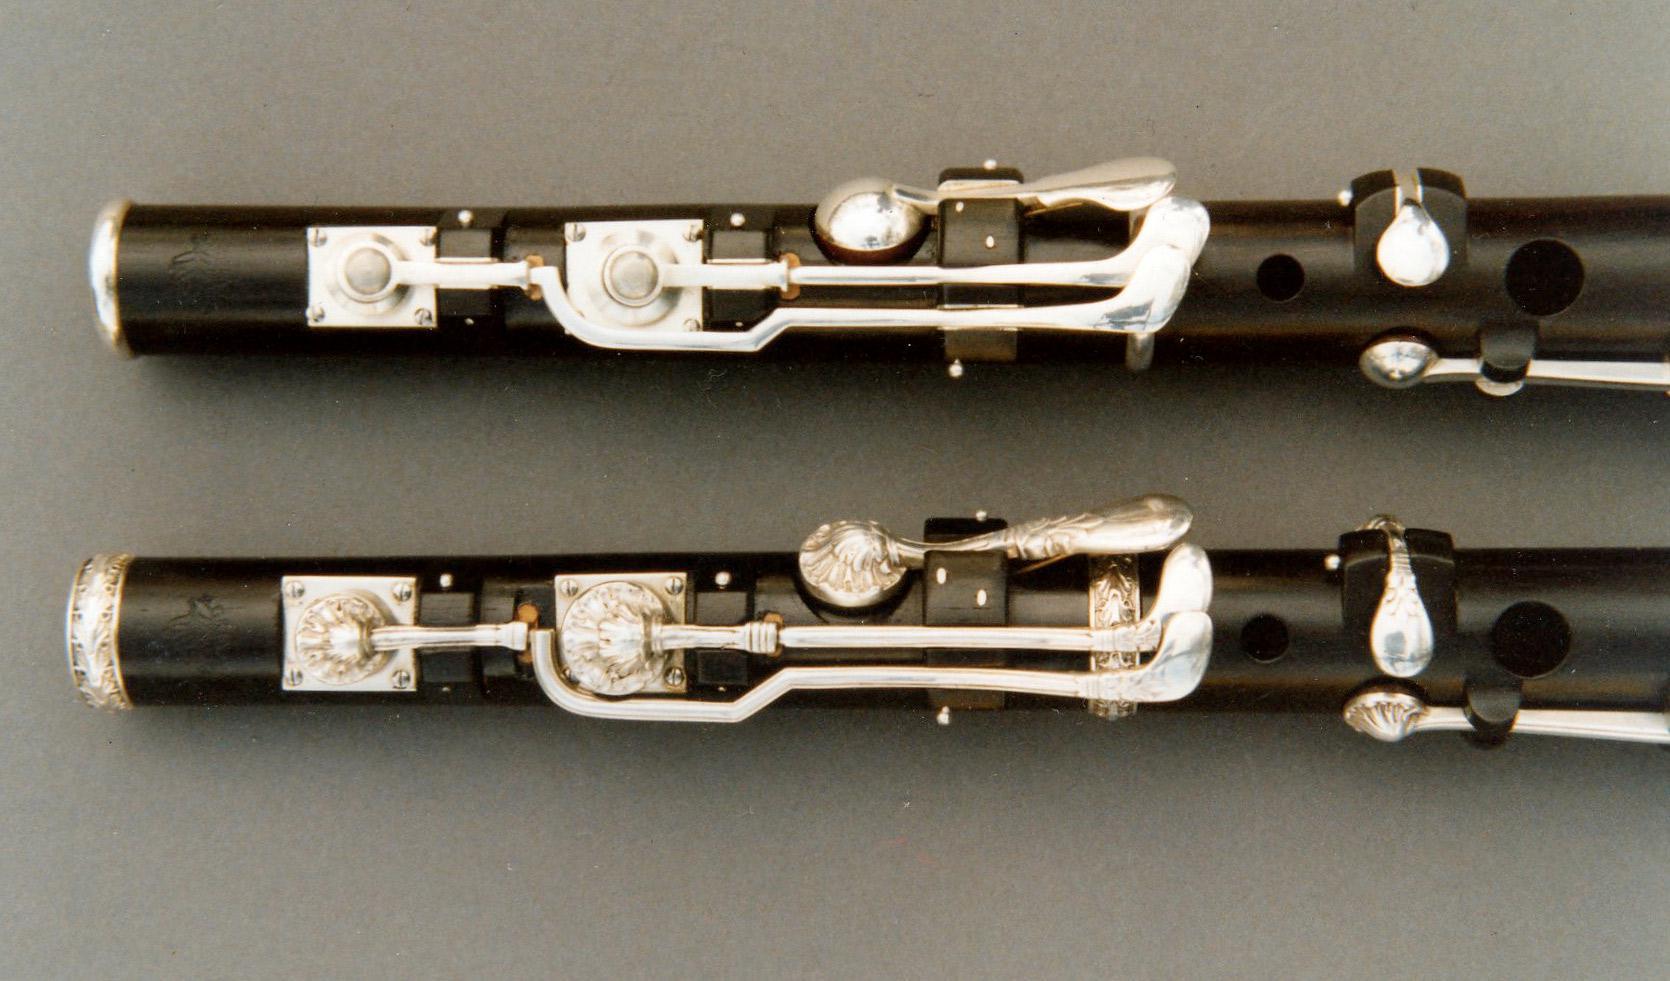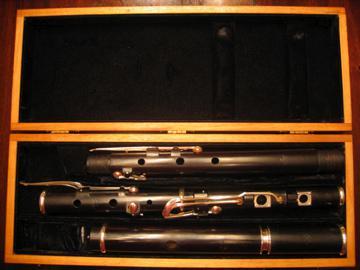The first image is the image on the left, the second image is the image on the right. Analyze the images presented: Is the assertion "In the image on the right, a brown and black case contains at least 2 sections of a flute." valid? Answer yes or no. Yes. The first image is the image on the left, the second image is the image on the right. Examine the images to the left and right. Is the description "The right image features an open case and instrument parts that are not connected, and the left image includes multiple items displayed horizontally but not touching." accurate? Answer yes or no. Yes. 